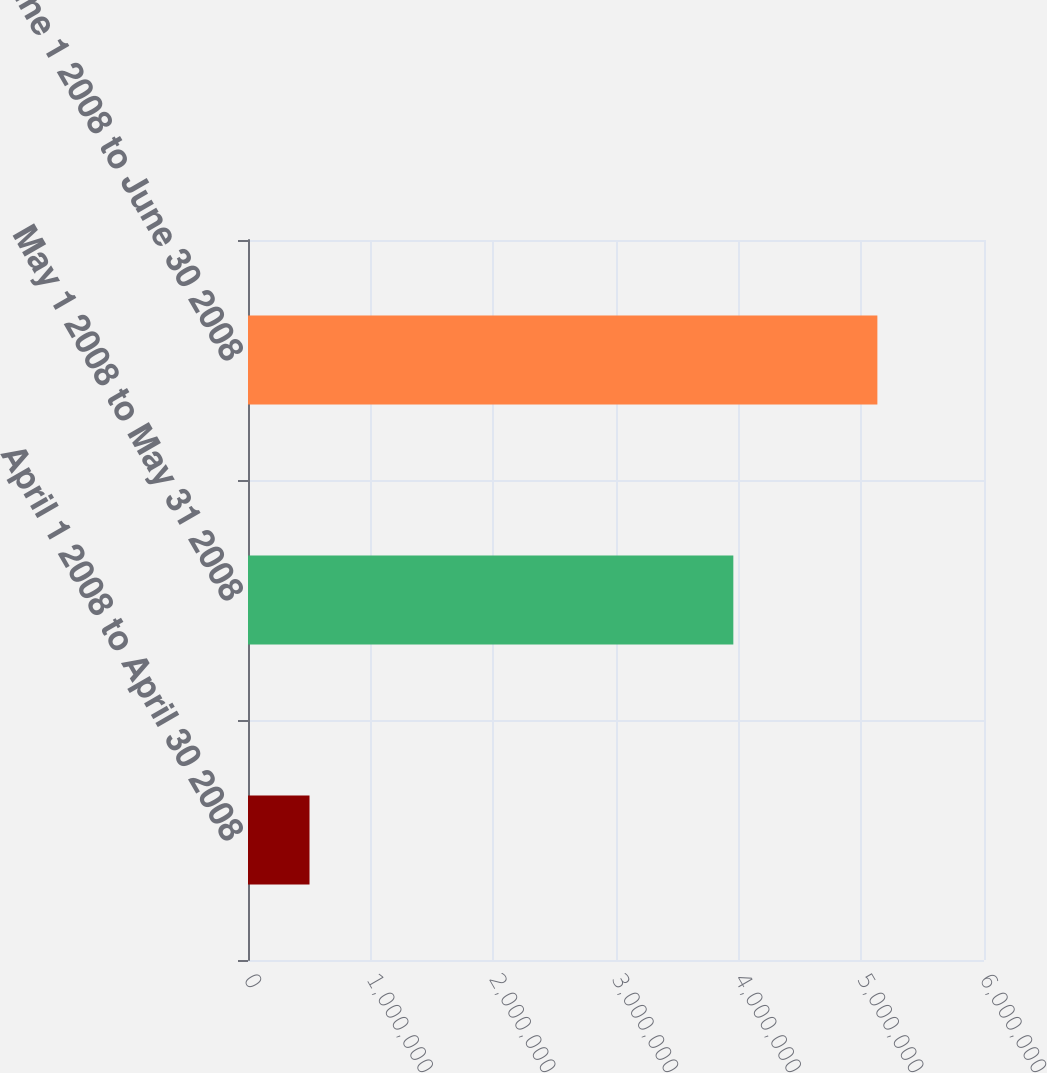<chart> <loc_0><loc_0><loc_500><loc_500><bar_chart><fcel>April 1 2008 to April 30 2008<fcel>May 1 2008 to May 31 2008<fcel>June 1 2008 to June 30 2008<nl><fcel>501500<fcel>3.9565e+06<fcel>5.1308e+06<nl></chart> 